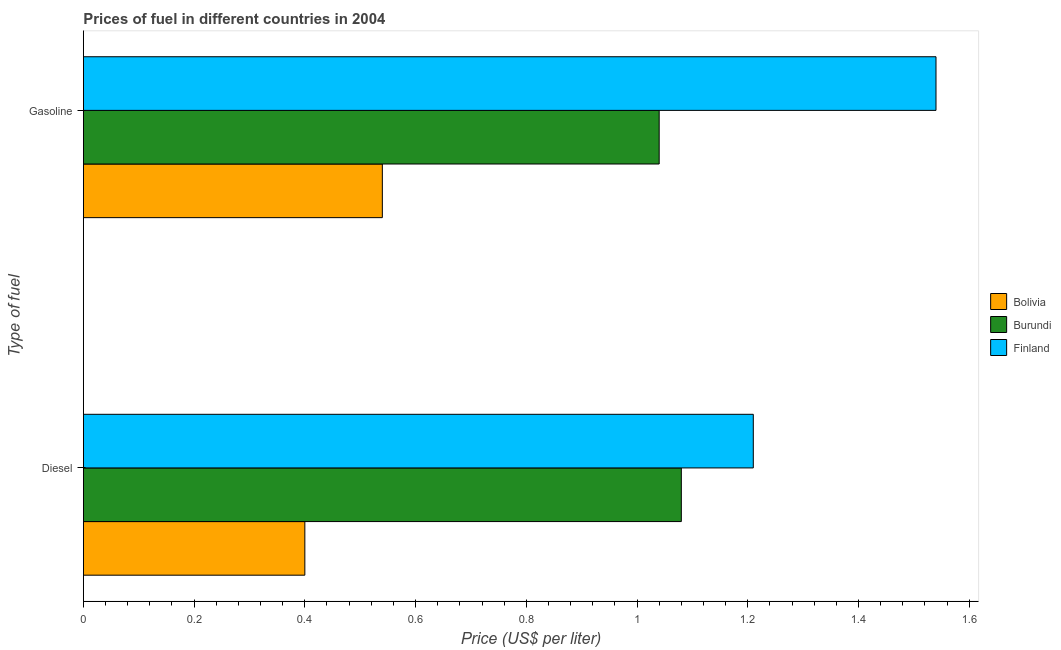Are the number of bars per tick equal to the number of legend labels?
Make the answer very short. Yes. How many bars are there on the 2nd tick from the top?
Your answer should be compact. 3. What is the label of the 1st group of bars from the top?
Your answer should be very brief. Gasoline. What is the diesel price in Finland?
Your response must be concise. 1.21. Across all countries, what is the maximum gasoline price?
Ensure brevity in your answer.  1.54. Across all countries, what is the minimum gasoline price?
Give a very brief answer. 0.54. In which country was the gasoline price maximum?
Your response must be concise. Finland. In which country was the gasoline price minimum?
Ensure brevity in your answer.  Bolivia. What is the total diesel price in the graph?
Offer a terse response. 2.69. What is the difference between the diesel price in Bolivia and that in Finland?
Offer a terse response. -0.81. What is the difference between the gasoline price in Burundi and the diesel price in Bolivia?
Your answer should be very brief. 0.64. What is the average gasoline price per country?
Your answer should be compact. 1.04. What is the difference between the gasoline price and diesel price in Finland?
Ensure brevity in your answer.  0.33. In how many countries, is the diesel price greater than 0.2 US$ per litre?
Provide a short and direct response. 3. What is the ratio of the gasoline price in Burundi to that in Finland?
Ensure brevity in your answer.  0.68. What does the 2nd bar from the bottom in Diesel represents?
Your response must be concise. Burundi. Are all the bars in the graph horizontal?
Give a very brief answer. Yes. How many countries are there in the graph?
Ensure brevity in your answer.  3. What is the difference between two consecutive major ticks on the X-axis?
Offer a terse response. 0.2. Does the graph contain any zero values?
Your response must be concise. No. What is the title of the graph?
Provide a succinct answer. Prices of fuel in different countries in 2004. What is the label or title of the X-axis?
Ensure brevity in your answer.  Price (US$ per liter). What is the label or title of the Y-axis?
Offer a terse response. Type of fuel. What is the Price (US$ per liter) in Bolivia in Diesel?
Your response must be concise. 0.4. What is the Price (US$ per liter) in Burundi in Diesel?
Ensure brevity in your answer.  1.08. What is the Price (US$ per liter) in Finland in Diesel?
Ensure brevity in your answer.  1.21. What is the Price (US$ per liter) in Bolivia in Gasoline?
Provide a succinct answer. 0.54. What is the Price (US$ per liter) in Burundi in Gasoline?
Your response must be concise. 1.04. What is the Price (US$ per liter) in Finland in Gasoline?
Provide a succinct answer. 1.54. Across all Type of fuel, what is the maximum Price (US$ per liter) of Bolivia?
Provide a succinct answer. 0.54. Across all Type of fuel, what is the maximum Price (US$ per liter) of Finland?
Provide a short and direct response. 1.54. Across all Type of fuel, what is the minimum Price (US$ per liter) in Finland?
Give a very brief answer. 1.21. What is the total Price (US$ per liter) of Burundi in the graph?
Make the answer very short. 2.12. What is the total Price (US$ per liter) in Finland in the graph?
Provide a short and direct response. 2.75. What is the difference between the Price (US$ per liter) in Bolivia in Diesel and that in Gasoline?
Offer a very short reply. -0.14. What is the difference between the Price (US$ per liter) of Finland in Diesel and that in Gasoline?
Make the answer very short. -0.33. What is the difference between the Price (US$ per liter) in Bolivia in Diesel and the Price (US$ per liter) in Burundi in Gasoline?
Offer a very short reply. -0.64. What is the difference between the Price (US$ per liter) in Bolivia in Diesel and the Price (US$ per liter) in Finland in Gasoline?
Provide a short and direct response. -1.14. What is the difference between the Price (US$ per liter) in Burundi in Diesel and the Price (US$ per liter) in Finland in Gasoline?
Ensure brevity in your answer.  -0.46. What is the average Price (US$ per liter) of Bolivia per Type of fuel?
Offer a terse response. 0.47. What is the average Price (US$ per liter) of Burundi per Type of fuel?
Offer a terse response. 1.06. What is the average Price (US$ per liter) in Finland per Type of fuel?
Offer a terse response. 1.38. What is the difference between the Price (US$ per liter) of Bolivia and Price (US$ per liter) of Burundi in Diesel?
Offer a very short reply. -0.68. What is the difference between the Price (US$ per liter) of Bolivia and Price (US$ per liter) of Finland in Diesel?
Offer a terse response. -0.81. What is the difference between the Price (US$ per liter) in Burundi and Price (US$ per liter) in Finland in Diesel?
Give a very brief answer. -0.13. What is the difference between the Price (US$ per liter) in Bolivia and Price (US$ per liter) in Finland in Gasoline?
Your answer should be compact. -1. What is the difference between the Price (US$ per liter) in Burundi and Price (US$ per liter) in Finland in Gasoline?
Provide a succinct answer. -0.5. What is the ratio of the Price (US$ per liter) of Bolivia in Diesel to that in Gasoline?
Provide a succinct answer. 0.74. What is the ratio of the Price (US$ per liter) in Burundi in Diesel to that in Gasoline?
Your answer should be very brief. 1.04. What is the ratio of the Price (US$ per liter) of Finland in Diesel to that in Gasoline?
Ensure brevity in your answer.  0.79. What is the difference between the highest and the second highest Price (US$ per liter) in Bolivia?
Ensure brevity in your answer.  0.14. What is the difference between the highest and the second highest Price (US$ per liter) of Finland?
Your answer should be compact. 0.33. What is the difference between the highest and the lowest Price (US$ per liter) in Bolivia?
Ensure brevity in your answer.  0.14. What is the difference between the highest and the lowest Price (US$ per liter) of Finland?
Give a very brief answer. 0.33. 